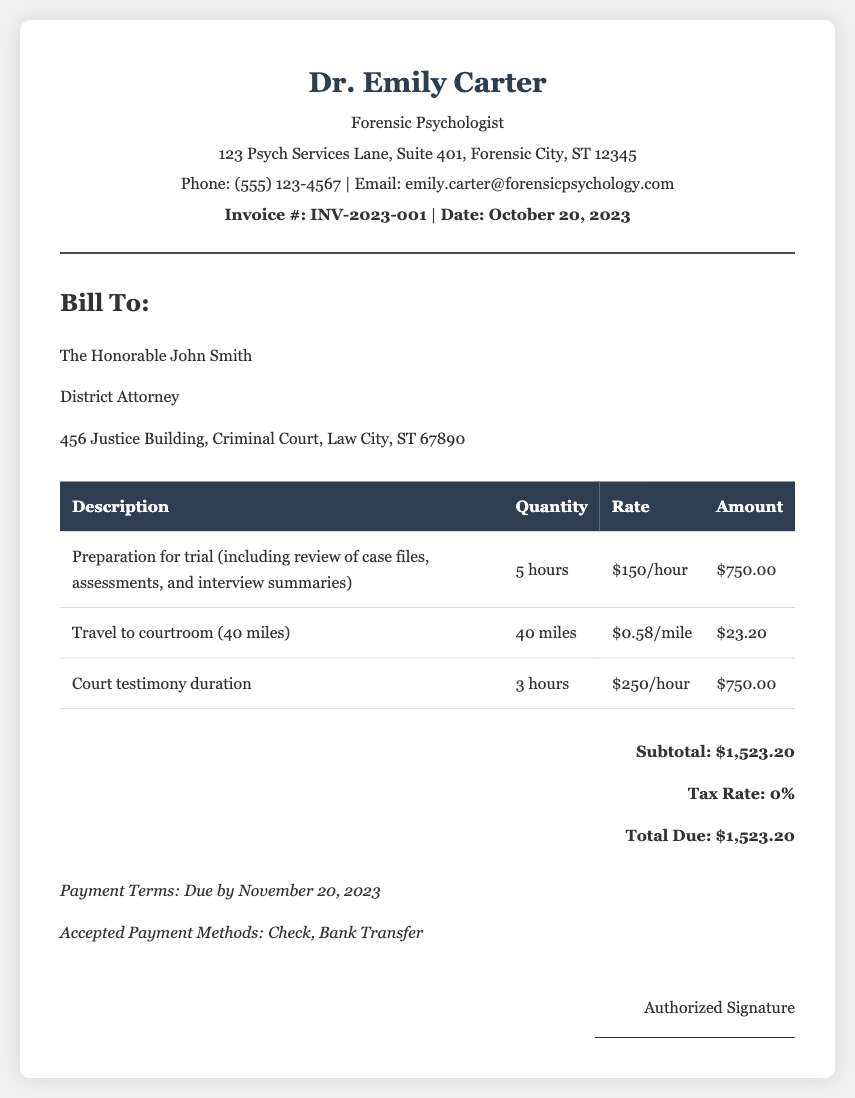What is the invoice number? The invoice number is specified at the top of the document under the title and is represented as INV-2023-001.
Answer: INV-2023-001 What is the total due amount? The total due amount is found in the summary section of the invoice and is the final count of charges including all included fees.
Answer: $1,523.20 How many hours were billed for preparation? The number of hours billed for preparation is provided in the services section of the document as part of the description.
Answer: 5 hours What is the rate for court testimony? The document lists the rate for court testimony in the services table, which reflects the cost associated with providing testimony.
Answer: $250/hour How far did the expert travel to the courtroom? The travel distance to the courtroom is clearly mentioned in the travel services section, indicating how many miles were incurred.
Answer: 40 miles What is the payment due date? The payment due date is stated in the payment terms section of the document and indicates when payment should be made.
Answer: November 20, 2023 What is the tax rate for the invoice? The tax rate is specified in the summary section and indicates whether tax is being applied to the total due amount.
Answer: 0% What is the total charge for travel expenses? The total charge for travel expenses can be found in the services section where it summarizes the travel cost incurred by the expert.
Answer: $23.20 Who is the invoice billed to? The invoice is addressed to a specific person and title, which is provided in the client information section of the document.
Answer: The Honorable John Smith 